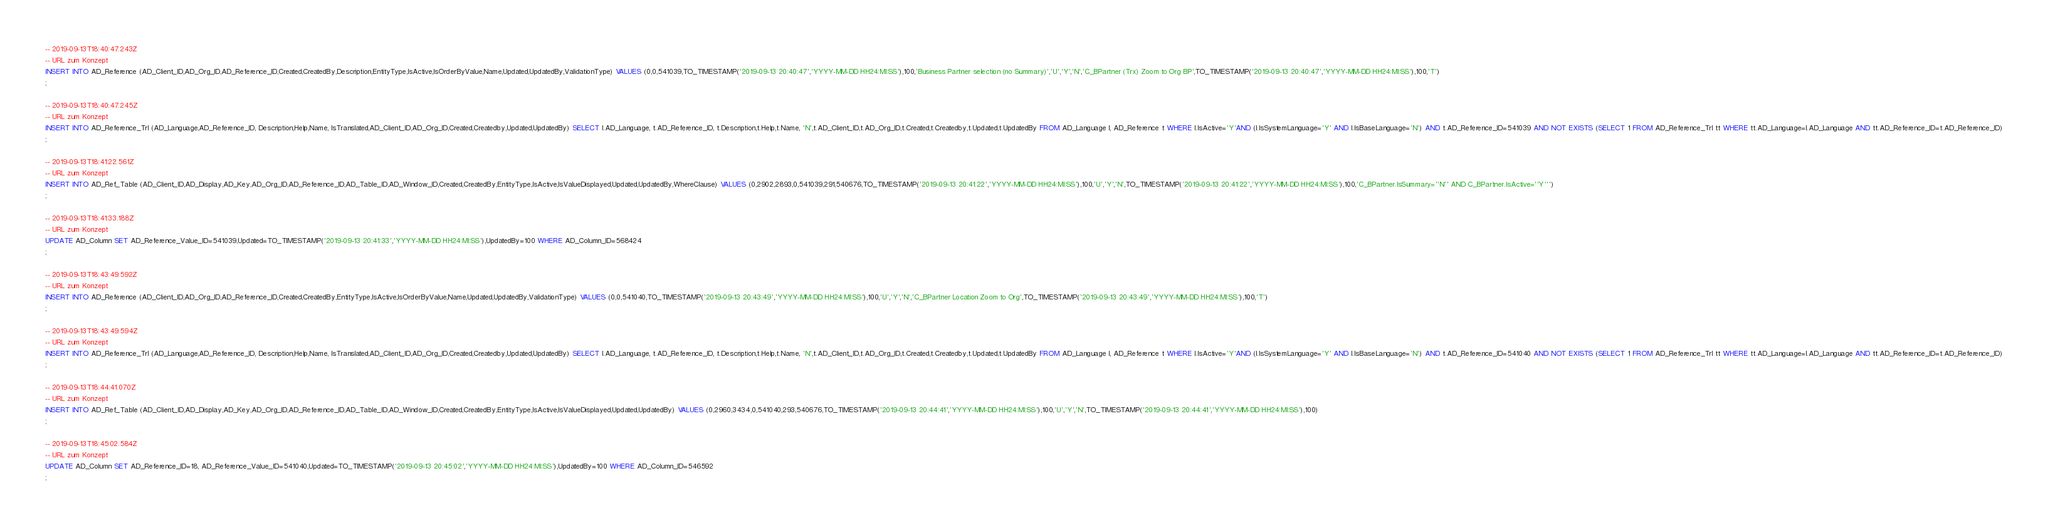Convert code to text. <code><loc_0><loc_0><loc_500><loc_500><_SQL_>-- 2019-09-13T18:40:47.243Z
-- URL zum Konzept
INSERT INTO AD_Reference (AD_Client_ID,AD_Org_ID,AD_Reference_ID,Created,CreatedBy,Description,EntityType,IsActive,IsOrderByValue,Name,Updated,UpdatedBy,ValidationType) VALUES (0,0,541039,TO_TIMESTAMP('2019-09-13 20:40:47','YYYY-MM-DD HH24:MI:SS'),100,'Business Partner selection (no Summary)','U','Y','N','C_BPartner (Trx) Zoom to Org BP',TO_TIMESTAMP('2019-09-13 20:40:47','YYYY-MM-DD HH24:MI:SS'),100,'T')
;

-- 2019-09-13T18:40:47.245Z
-- URL zum Konzept
INSERT INTO AD_Reference_Trl (AD_Language,AD_Reference_ID, Description,Help,Name, IsTranslated,AD_Client_ID,AD_Org_ID,Created,Createdby,Updated,UpdatedBy) SELECT l.AD_Language, t.AD_Reference_ID, t.Description,t.Help,t.Name, 'N',t.AD_Client_ID,t.AD_Org_ID,t.Created,t.Createdby,t.Updated,t.UpdatedBy FROM AD_Language l, AD_Reference t WHERE l.IsActive='Y'AND (l.IsSystemLanguage='Y' AND l.IsBaseLanguage='N') AND t.AD_Reference_ID=541039 AND NOT EXISTS (SELECT 1 FROM AD_Reference_Trl tt WHERE tt.AD_Language=l.AD_Language AND tt.AD_Reference_ID=t.AD_Reference_ID)
;

-- 2019-09-13T18:41:22.561Z
-- URL zum Konzept
INSERT INTO AD_Ref_Table (AD_Client_ID,AD_Display,AD_Key,AD_Org_ID,AD_Reference_ID,AD_Table_ID,AD_Window_ID,Created,CreatedBy,EntityType,IsActive,IsValueDisplayed,Updated,UpdatedBy,WhereClause) VALUES (0,2902,2893,0,541039,291,540676,TO_TIMESTAMP('2019-09-13 20:41:22','YYYY-MM-DD HH24:MI:SS'),100,'U','Y','N',TO_TIMESTAMP('2019-09-13 20:41:22','YYYY-MM-DD HH24:MI:SS'),100,'C_BPartner.IsSummary=''N'' AND C_BPartner.IsActive=''Y''')
;

-- 2019-09-13T18:41:33.188Z
-- URL zum Konzept
UPDATE AD_Column SET AD_Reference_Value_ID=541039,Updated=TO_TIMESTAMP('2019-09-13 20:41:33','YYYY-MM-DD HH24:MI:SS'),UpdatedBy=100 WHERE AD_Column_ID=568424
;

-- 2019-09-13T18:43:49.592Z
-- URL zum Konzept
INSERT INTO AD_Reference (AD_Client_ID,AD_Org_ID,AD_Reference_ID,Created,CreatedBy,EntityType,IsActive,IsOrderByValue,Name,Updated,UpdatedBy,ValidationType) VALUES (0,0,541040,TO_TIMESTAMP('2019-09-13 20:43:49','YYYY-MM-DD HH24:MI:SS'),100,'U','Y','N','C_BPartner Location Zoom to Org',TO_TIMESTAMP('2019-09-13 20:43:49','YYYY-MM-DD HH24:MI:SS'),100,'T')
;

-- 2019-09-13T18:43:49.594Z
-- URL zum Konzept
INSERT INTO AD_Reference_Trl (AD_Language,AD_Reference_ID, Description,Help,Name, IsTranslated,AD_Client_ID,AD_Org_ID,Created,Createdby,Updated,UpdatedBy) SELECT l.AD_Language, t.AD_Reference_ID, t.Description,t.Help,t.Name, 'N',t.AD_Client_ID,t.AD_Org_ID,t.Created,t.Createdby,t.Updated,t.UpdatedBy FROM AD_Language l, AD_Reference t WHERE l.IsActive='Y'AND (l.IsSystemLanguage='Y' AND l.IsBaseLanguage='N') AND t.AD_Reference_ID=541040 AND NOT EXISTS (SELECT 1 FROM AD_Reference_Trl tt WHERE tt.AD_Language=l.AD_Language AND tt.AD_Reference_ID=t.AD_Reference_ID)
;

-- 2019-09-13T18:44:41.070Z
-- URL zum Konzept
INSERT INTO AD_Ref_Table (AD_Client_ID,AD_Display,AD_Key,AD_Org_ID,AD_Reference_ID,AD_Table_ID,AD_Window_ID,Created,CreatedBy,EntityType,IsActive,IsValueDisplayed,Updated,UpdatedBy) VALUES (0,2960,3434,0,541040,293,540676,TO_TIMESTAMP('2019-09-13 20:44:41','YYYY-MM-DD HH24:MI:SS'),100,'U','Y','N',TO_TIMESTAMP('2019-09-13 20:44:41','YYYY-MM-DD HH24:MI:SS'),100)
;

-- 2019-09-13T18:45:02.584Z
-- URL zum Konzept
UPDATE AD_Column SET AD_Reference_ID=18, AD_Reference_Value_ID=541040,Updated=TO_TIMESTAMP('2019-09-13 20:45:02','YYYY-MM-DD HH24:MI:SS'),UpdatedBy=100 WHERE AD_Column_ID=546592
;

</code> 